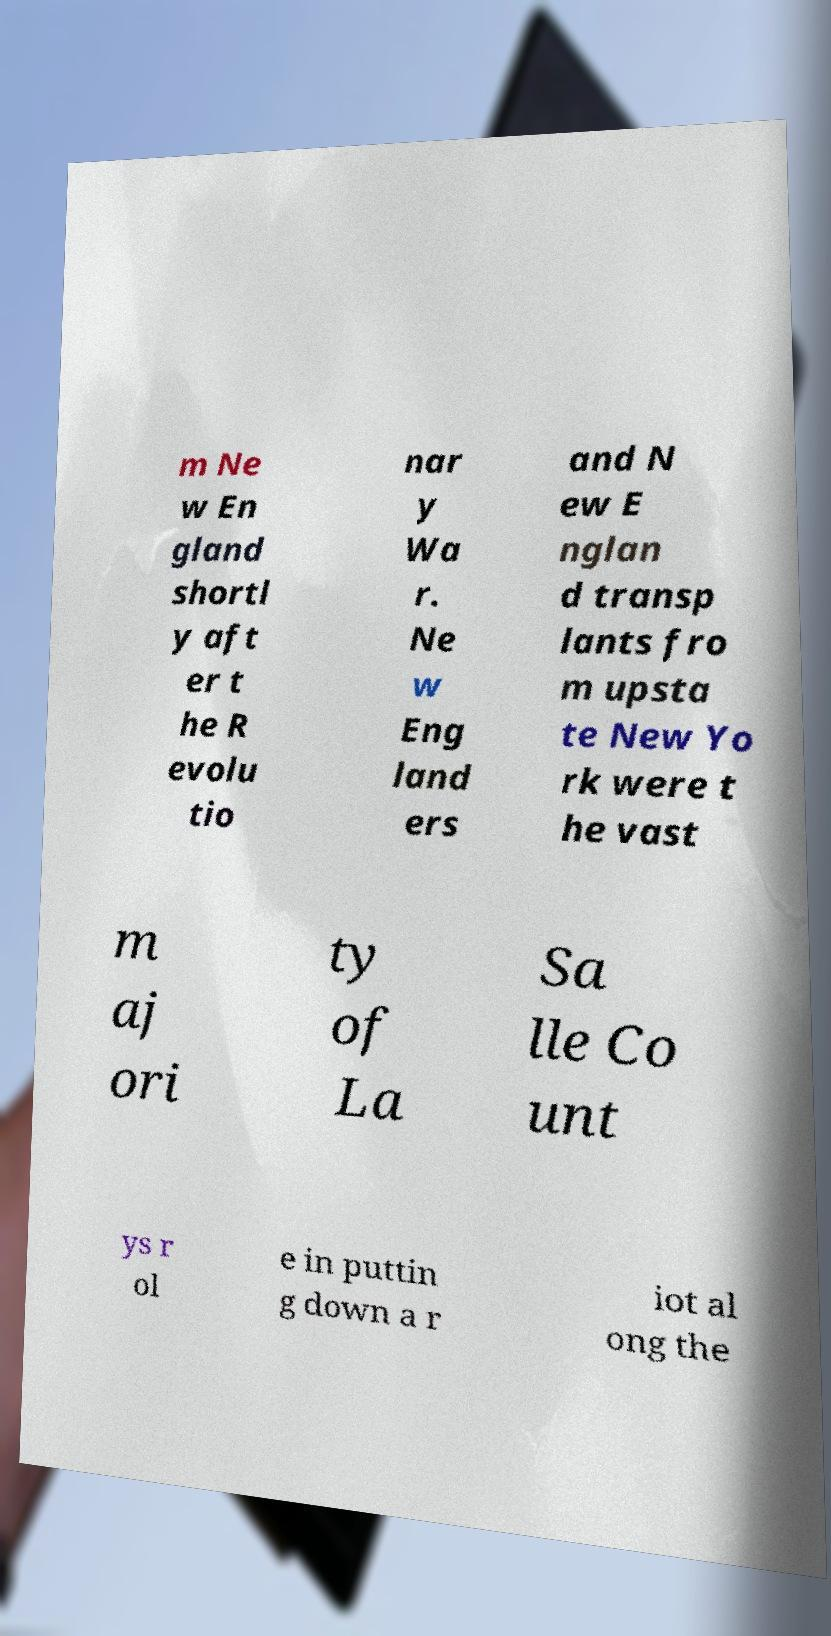Please identify and transcribe the text found in this image. m Ne w En gland shortl y aft er t he R evolu tio nar y Wa r. Ne w Eng land ers and N ew E nglan d transp lants fro m upsta te New Yo rk were t he vast m aj ori ty of La Sa lle Co unt ys r ol e in puttin g down a r iot al ong the 